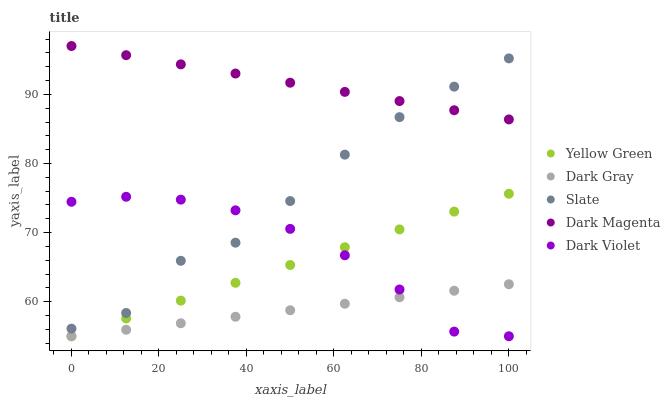Does Dark Gray have the minimum area under the curve?
Answer yes or no. Yes. Does Dark Magenta have the maximum area under the curve?
Answer yes or no. Yes. Does Slate have the minimum area under the curve?
Answer yes or no. No. Does Slate have the maximum area under the curve?
Answer yes or no. No. Is Yellow Green the smoothest?
Answer yes or no. Yes. Is Slate the roughest?
Answer yes or no. Yes. Is Slate the smoothest?
Answer yes or no. No. Is Yellow Green the roughest?
Answer yes or no. No. Does Dark Gray have the lowest value?
Answer yes or no. Yes. Does Slate have the lowest value?
Answer yes or no. No. Does Dark Magenta have the highest value?
Answer yes or no. Yes. Does Slate have the highest value?
Answer yes or no. No. Is Yellow Green less than Slate?
Answer yes or no. Yes. Is Dark Magenta greater than Dark Gray?
Answer yes or no. Yes. Does Dark Magenta intersect Slate?
Answer yes or no. Yes. Is Dark Magenta less than Slate?
Answer yes or no. No. Is Dark Magenta greater than Slate?
Answer yes or no. No. Does Yellow Green intersect Slate?
Answer yes or no. No. 